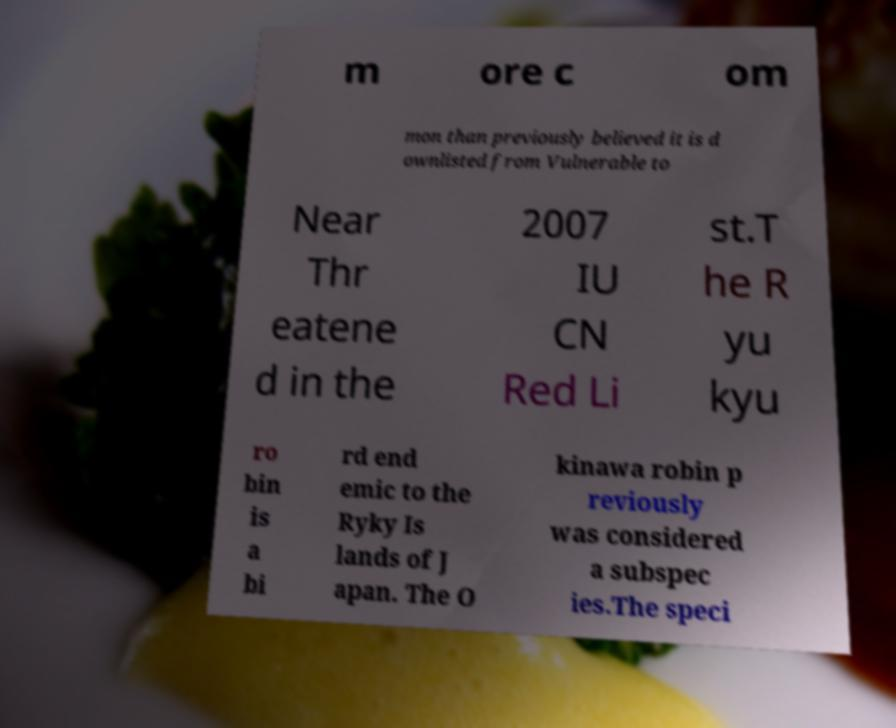There's text embedded in this image that I need extracted. Can you transcribe it verbatim? m ore c om mon than previously believed it is d ownlisted from Vulnerable to Near Thr eatene d in the 2007 IU CN Red Li st.T he R yu kyu ro bin is a bi rd end emic to the Ryky Is lands of J apan. The O kinawa robin p reviously was considered a subspec ies.The speci 